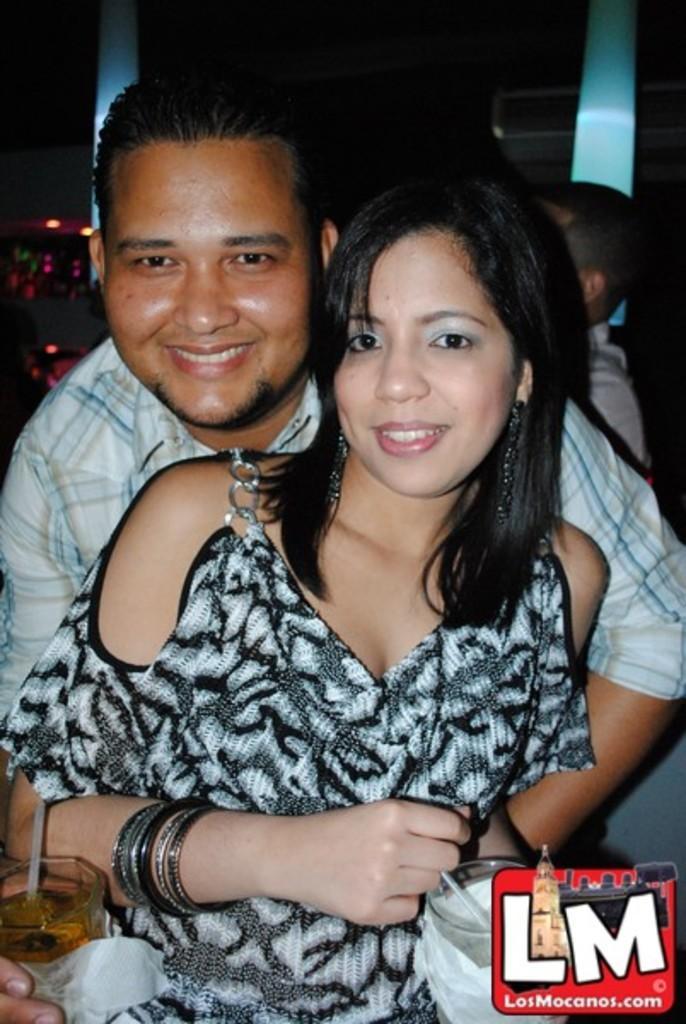Can you describe this image briefly? In this image we can see a man and a woman. They are holding glasses with their hands and smiling. There is a dark background and we can see a person. At the bottom of the image we can see a logo. 